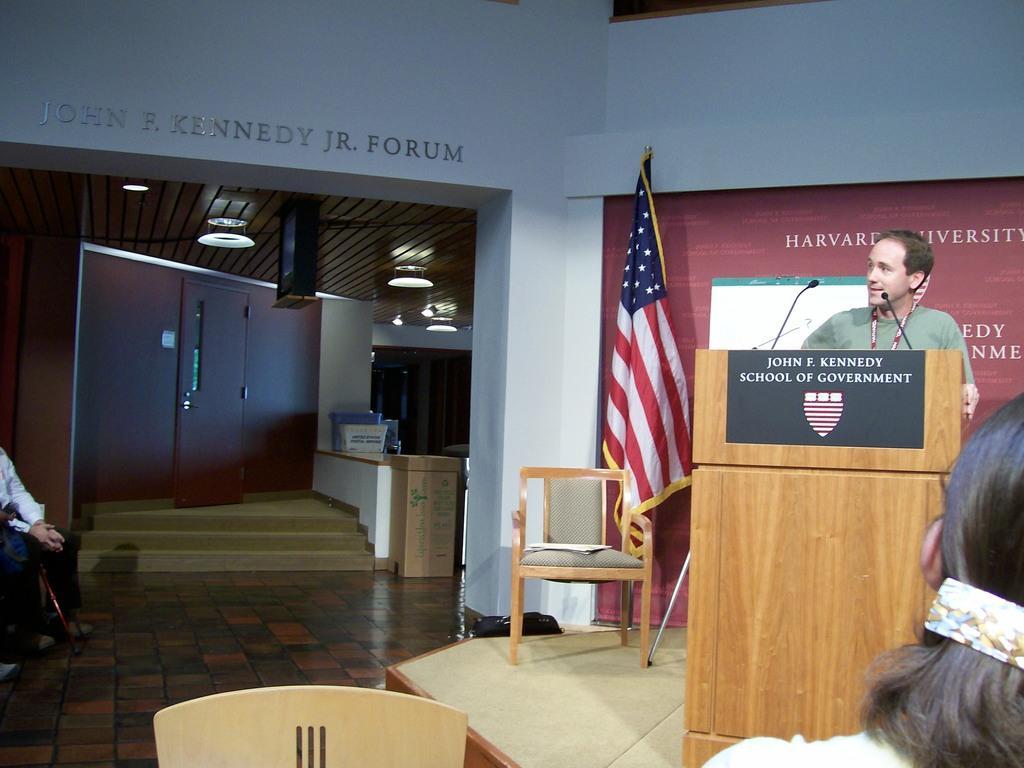Can you describe this image briefly? In this image I see a man who is standing in front of a podium and there are mics on it. I can also see few people who are sitting on chairs and I see another chair over here. In the background I see the board on which there are few words and I see a flag ,steps, door and lights on the ceiling. 